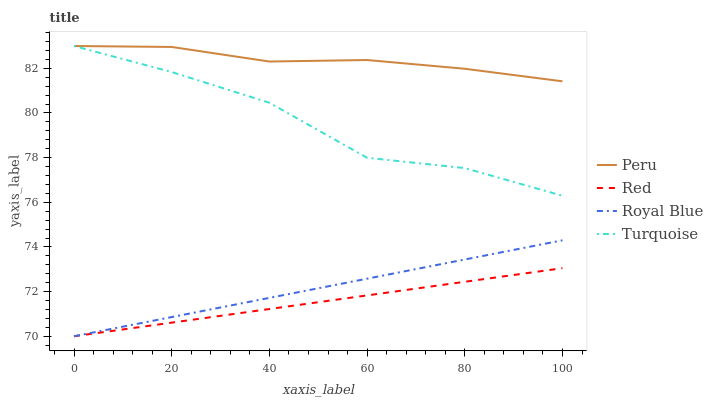Does Red have the minimum area under the curve?
Answer yes or no. Yes. Does Peru have the maximum area under the curve?
Answer yes or no. Yes. Does Turquoise have the minimum area under the curve?
Answer yes or no. No. Does Turquoise have the maximum area under the curve?
Answer yes or no. No. Is Red the smoothest?
Answer yes or no. Yes. Is Turquoise the roughest?
Answer yes or no. Yes. Is Turquoise the smoothest?
Answer yes or no. No. Is Red the roughest?
Answer yes or no. No. Does Turquoise have the lowest value?
Answer yes or no. No. Does Red have the highest value?
Answer yes or no. No. Is Red less than Peru?
Answer yes or no. Yes. Is Peru greater than Red?
Answer yes or no. Yes. Does Red intersect Peru?
Answer yes or no. No. 